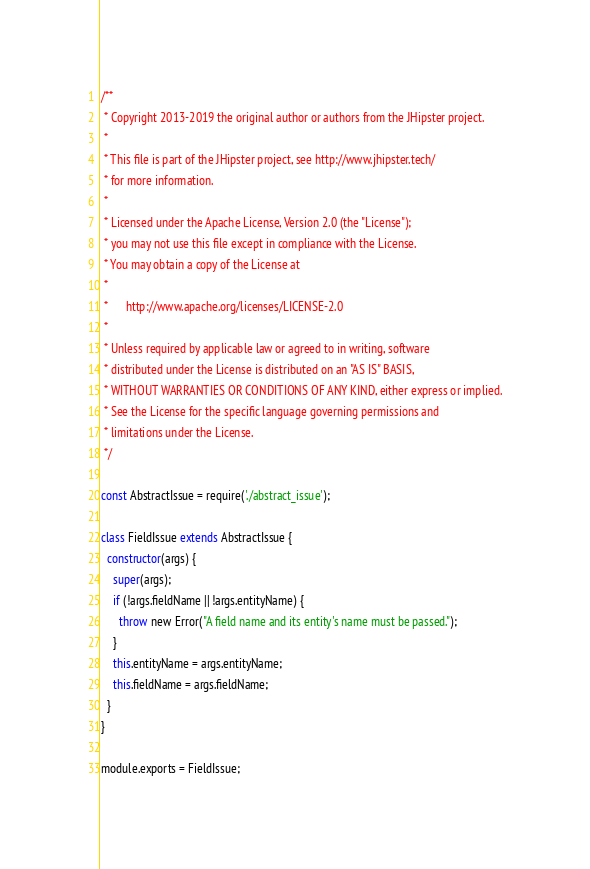<code> <loc_0><loc_0><loc_500><loc_500><_JavaScript_>/**
 * Copyright 2013-2019 the original author or authors from the JHipster project.
 *
 * This file is part of the JHipster project, see http://www.jhipster.tech/
 * for more information.
 *
 * Licensed under the Apache License, Version 2.0 (the "License");
 * you may not use this file except in compliance with the License.
 * You may obtain a copy of the License at
 *
 *      http://www.apache.org/licenses/LICENSE-2.0
 *
 * Unless required by applicable law or agreed to in writing, software
 * distributed under the License is distributed on an "AS IS" BASIS,
 * WITHOUT WARRANTIES OR CONDITIONS OF ANY KIND, either express or implied.
 * See the License for the specific language governing permissions and
 * limitations under the License.
 */

const AbstractIssue = require('./abstract_issue');

class FieldIssue extends AbstractIssue {
  constructor(args) {
    super(args);
    if (!args.fieldName || !args.entityName) {
      throw new Error("A field name and its entity's name must be passed.");
    }
    this.entityName = args.entityName;
    this.fieldName = args.fieldName;
  }
}

module.exports = FieldIssue;
</code> 